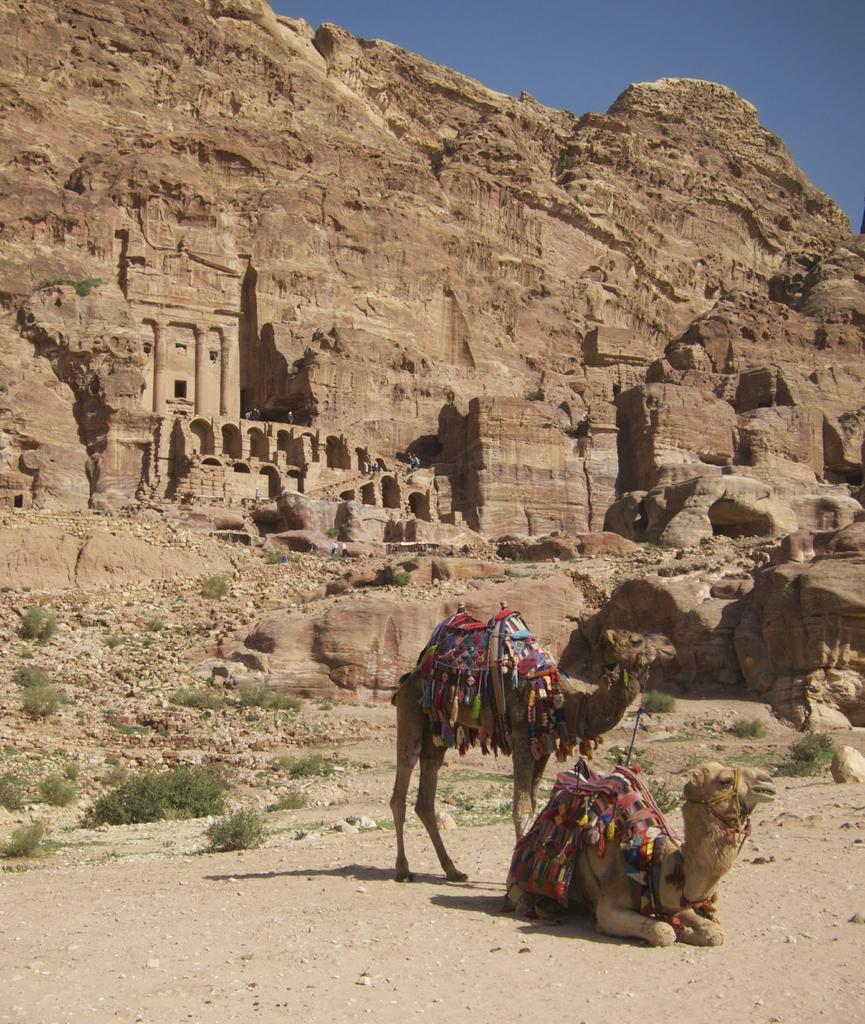Please provide a concise description of this image. In this picture we can see few camels, beside to the camels we can find few plants, in the background we can see a fort and a hill. 